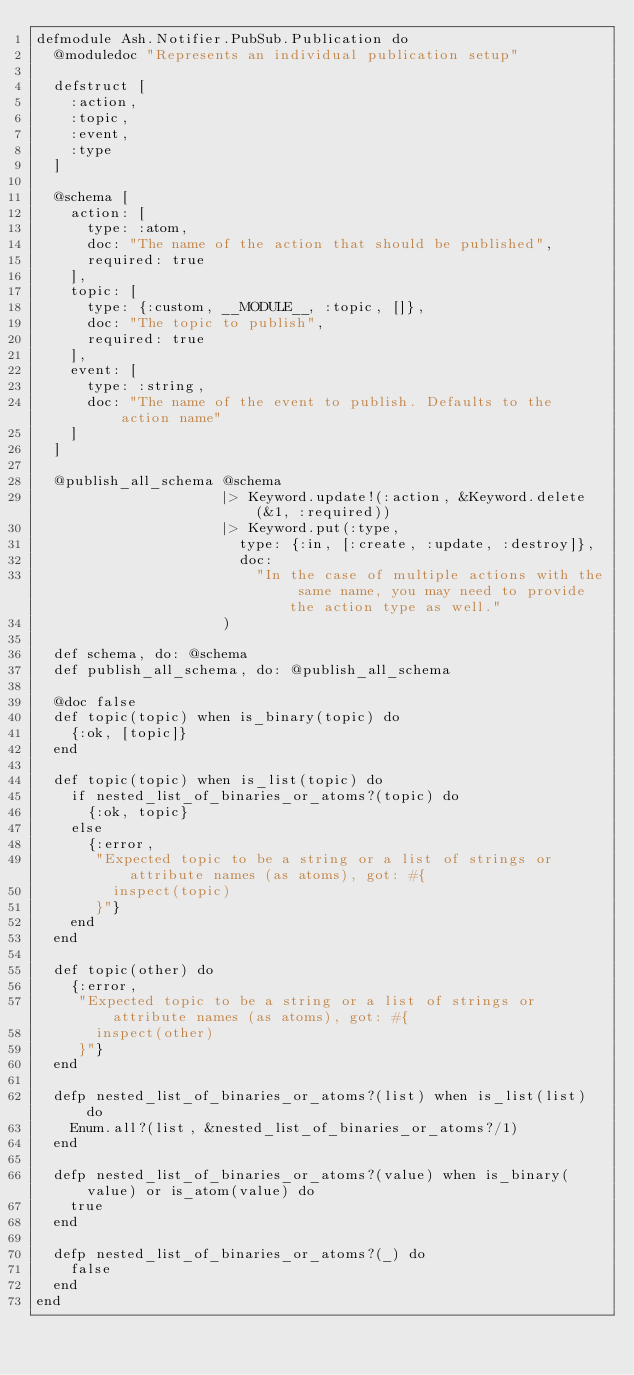Convert code to text. <code><loc_0><loc_0><loc_500><loc_500><_Elixir_>defmodule Ash.Notifier.PubSub.Publication do
  @moduledoc "Represents an individual publication setup"

  defstruct [
    :action,
    :topic,
    :event,
    :type
  ]

  @schema [
    action: [
      type: :atom,
      doc: "The name of the action that should be published",
      required: true
    ],
    topic: [
      type: {:custom, __MODULE__, :topic, []},
      doc: "The topic to publish",
      required: true
    ],
    event: [
      type: :string,
      doc: "The name of the event to publish. Defaults to the action name"
    ]
  ]

  @publish_all_schema @schema
                      |> Keyword.update!(:action, &Keyword.delete(&1, :required))
                      |> Keyword.put(:type,
                        type: {:in, [:create, :update, :destroy]},
                        doc:
                          "In the case of multiple actions with the same name, you may need to provide the action type as well."
                      )

  def schema, do: @schema
  def publish_all_schema, do: @publish_all_schema

  @doc false
  def topic(topic) when is_binary(topic) do
    {:ok, [topic]}
  end

  def topic(topic) when is_list(topic) do
    if nested_list_of_binaries_or_atoms?(topic) do
      {:ok, topic}
    else
      {:error,
       "Expected topic to be a string or a list of strings or attribute names (as atoms), got: #{
         inspect(topic)
       }"}
    end
  end

  def topic(other) do
    {:error,
     "Expected topic to be a string or a list of strings or attribute names (as atoms), got: #{
       inspect(other)
     }"}
  end

  defp nested_list_of_binaries_or_atoms?(list) when is_list(list) do
    Enum.all?(list, &nested_list_of_binaries_or_atoms?/1)
  end

  defp nested_list_of_binaries_or_atoms?(value) when is_binary(value) or is_atom(value) do
    true
  end

  defp nested_list_of_binaries_or_atoms?(_) do
    false
  end
end
</code> 